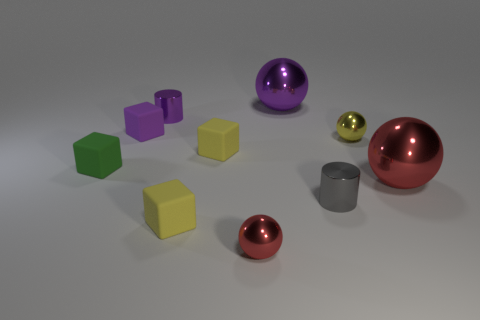Subtract all tiny yellow metal balls. How many balls are left? 3 Subtract all red spheres. Subtract all tiny cylinders. How many objects are left? 6 Add 6 tiny yellow shiny balls. How many tiny yellow shiny balls are left? 7 Add 7 small metallic balls. How many small metallic balls exist? 9 Subtract all yellow spheres. How many spheres are left? 3 Subtract 0 gray cubes. How many objects are left? 10 Subtract all cylinders. How many objects are left? 8 Subtract 3 balls. How many balls are left? 1 Subtract all cyan spheres. Subtract all yellow cylinders. How many spheres are left? 4 Subtract all red blocks. How many purple cylinders are left? 1 